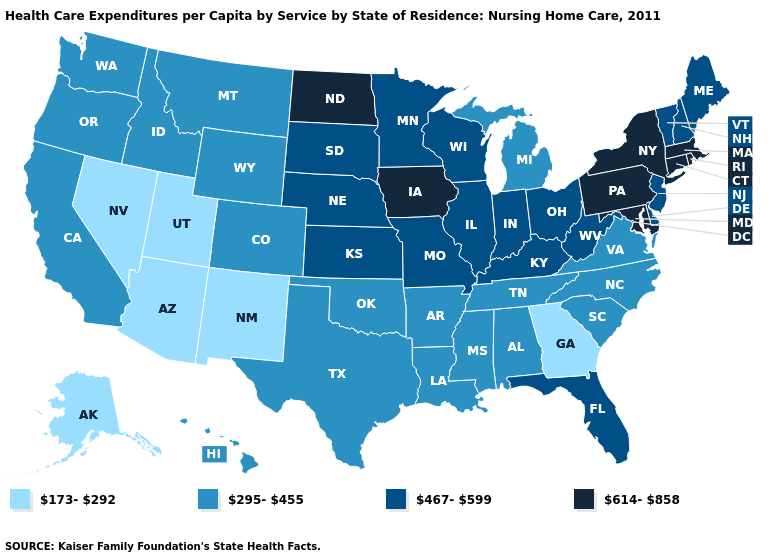What is the lowest value in the Northeast?
Give a very brief answer. 467-599. What is the highest value in the West ?
Be succinct. 295-455. What is the value of Texas?
Short answer required. 295-455. What is the value of Maine?
Give a very brief answer. 467-599. Does Maryland have the highest value in the South?
Write a very short answer. Yes. Name the states that have a value in the range 614-858?
Keep it brief. Connecticut, Iowa, Maryland, Massachusetts, New York, North Dakota, Pennsylvania, Rhode Island. Does the map have missing data?
Answer briefly. No. What is the highest value in the MidWest ?
Quick response, please. 614-858. Does New Hampshire have the lowest value in the Northeast?
Concise answer only. Yes. What is the value of Nevada?
Short answer required. 173-292. Does Alaska have the lowest value in the West?
Keep it brief. Yes. Does the map have missing data?
Answer briefly. No. Does Florida have the same value as Alabama?
Keep it brief. No. Which states have the highest value in the USA?
Give a very brief answer. Connecticut, Iowa, Maryland, Massachusetts, New York, North Dakota, Pennsylvania, Rhode Island. Among the states that border Nebraska , which have the lowest value?
Quick response, please. Colorado, Wyoming. 